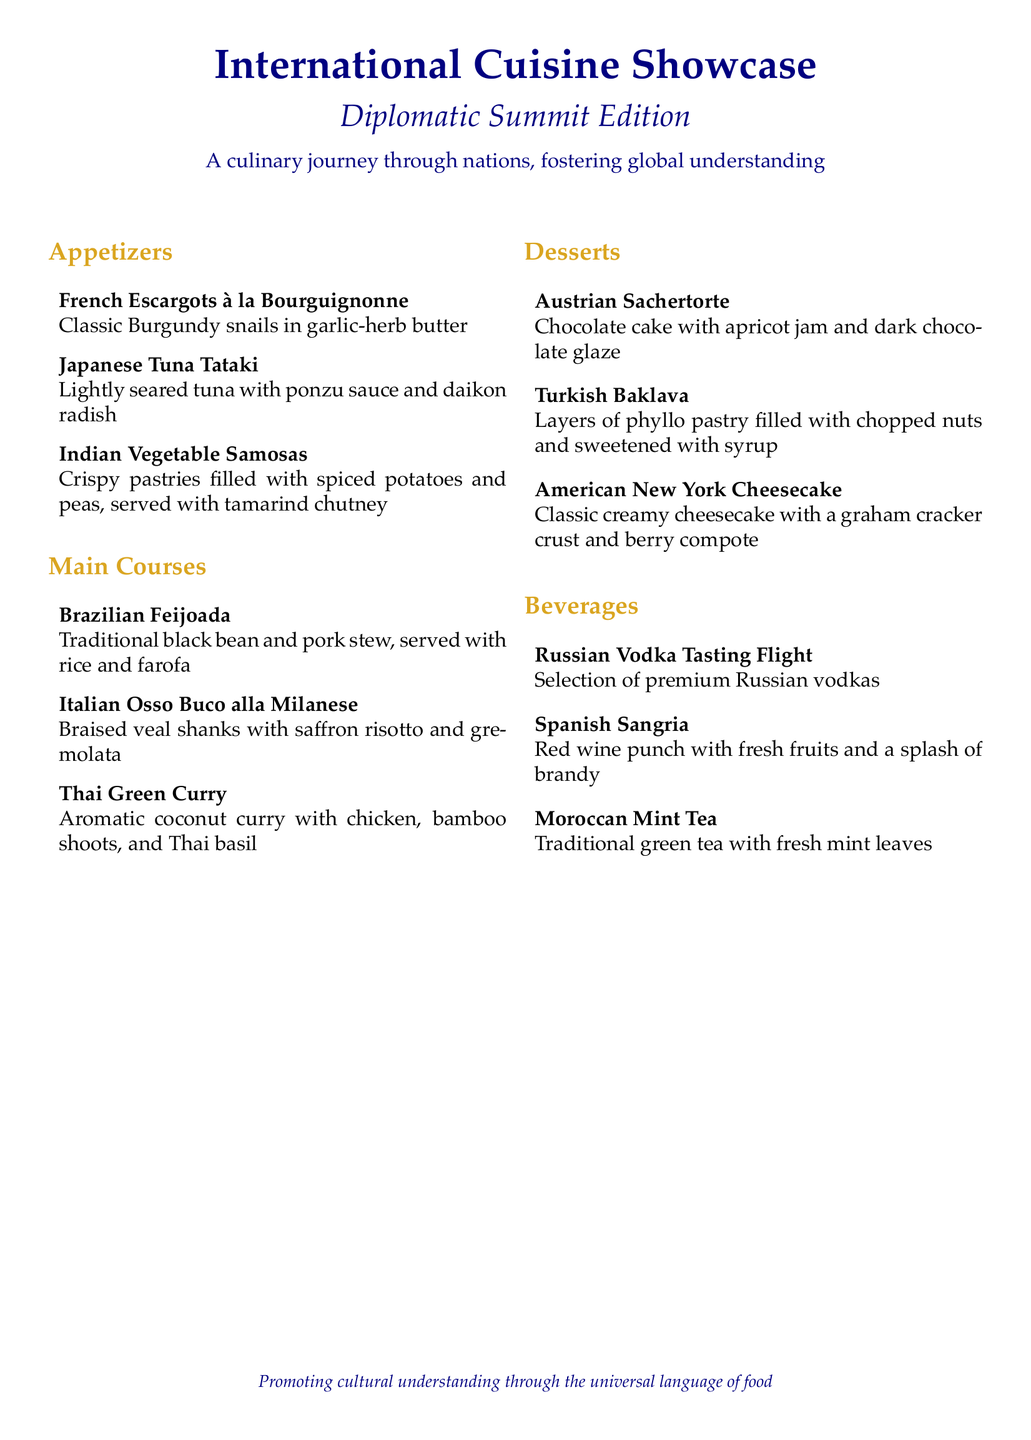What are the appetizers offered? The appetizers listed include French Escargots à la Bourguignonne, Japanese Tuna Tataki, and Indian Vegetable Samosas.
Answer: French Escargots à la Bourguignonne, Japanese Tuna Tataki, Indian Vegetable Samosas Which dessert features chocolate? The dessert that features chocolate is the Austrian Sachertorte, known for its chocolate cake and dark chocolate glaze.
Answer: Austrian Sachertorte How many main courses are listed? There are three main courses listed in the document.
Answer: Three What is the beverage that includes fresh mint? The beverage that includes fresh mint is Moroccan Mint Tea, which is traditional green tea with mint leaves.
Answer: Moroccan Mint Tea Which country's dish is a traditional black bean stew? The dish that is a traditional black bean stew is Brazilian Feijoada.
Answer: Brazilian Feijoada What is the main ingredient in Thai Green Curry? The main ingredient in Thai Green Curry is chicken, as indicated in the description of the dish.
Answer: Chicken What type of cuisine does the Turkish Baklava belong to? Turkish Baklava belongs to Turkish cuisine, identified by its layers of phyllo pastry and nuts.
Answer: Turkish What is served with the Italian Osso Buco alla Milanese? The Italian Osso Buco alla Milanese is served with saffron risotto and gremolata.
Answer: Saffron risotto and gremolata 